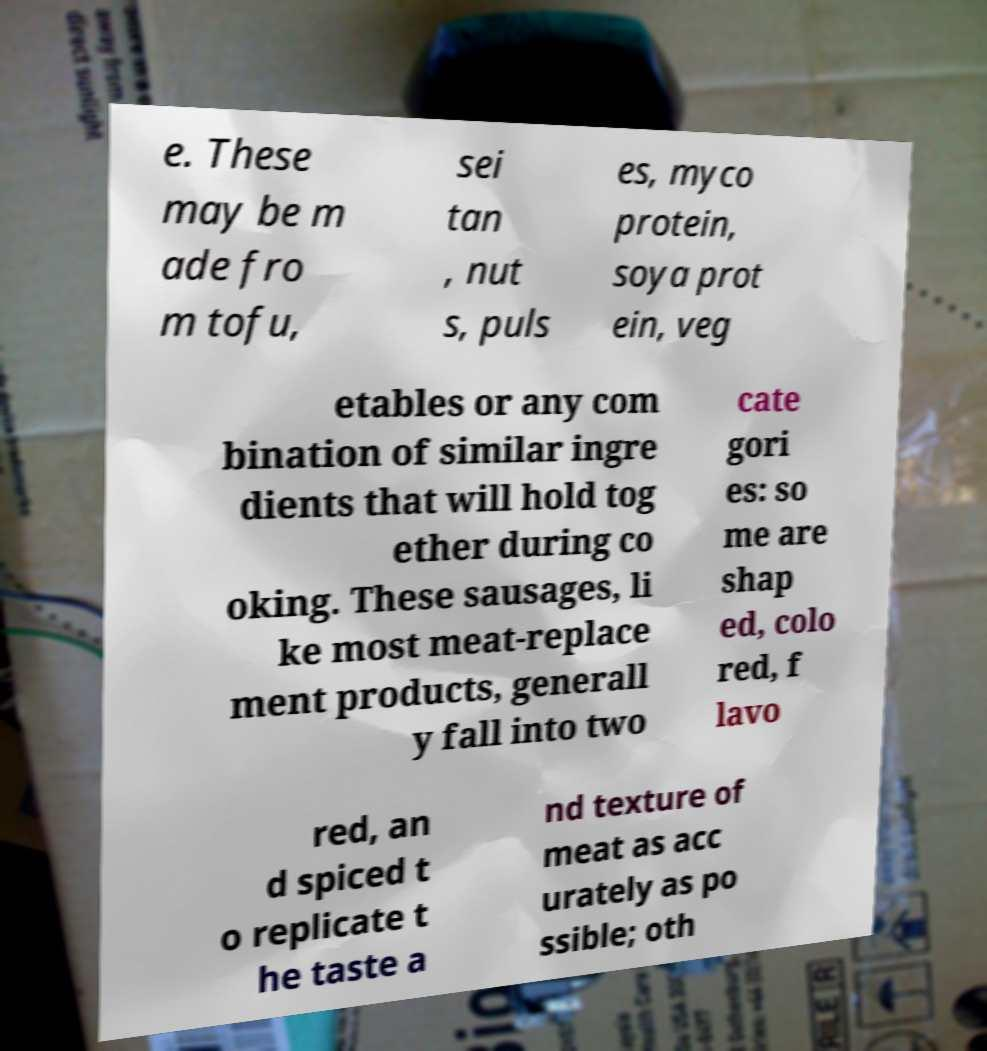Could you assist in decoding the text presented in this image and type it out clearly? e. These may be m ade fro m tofu, sei tan , nut s, puls es, myco protein, soya prot ein, veg etables or any com bination of similar ingre dients that will hold tog ether during co oking. These sausages, li ke most meat-replace ment products, generall y fall into two cate gori es: so me are shap ed, colo red, f lavo red, an d spiced t o replicate t he taste a nd texture of meat as acc urately as po ssible; oth 